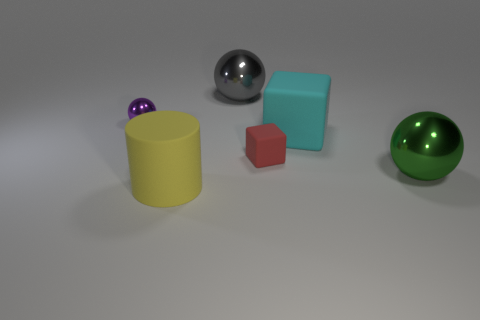Add 1 big blue matte balls. How many objects exist? 7 Subtract all cylinders. How many objects are left? 5 Add 2 big things. How many big things exist? 6 Subtract 0 brown balls. How many objects are left? 6 Subtract all red rubber things. Subtract all green metallic balls. How many objects are left? 4 Add 1 red matte blocks. How many red matte blocks are left? 2 